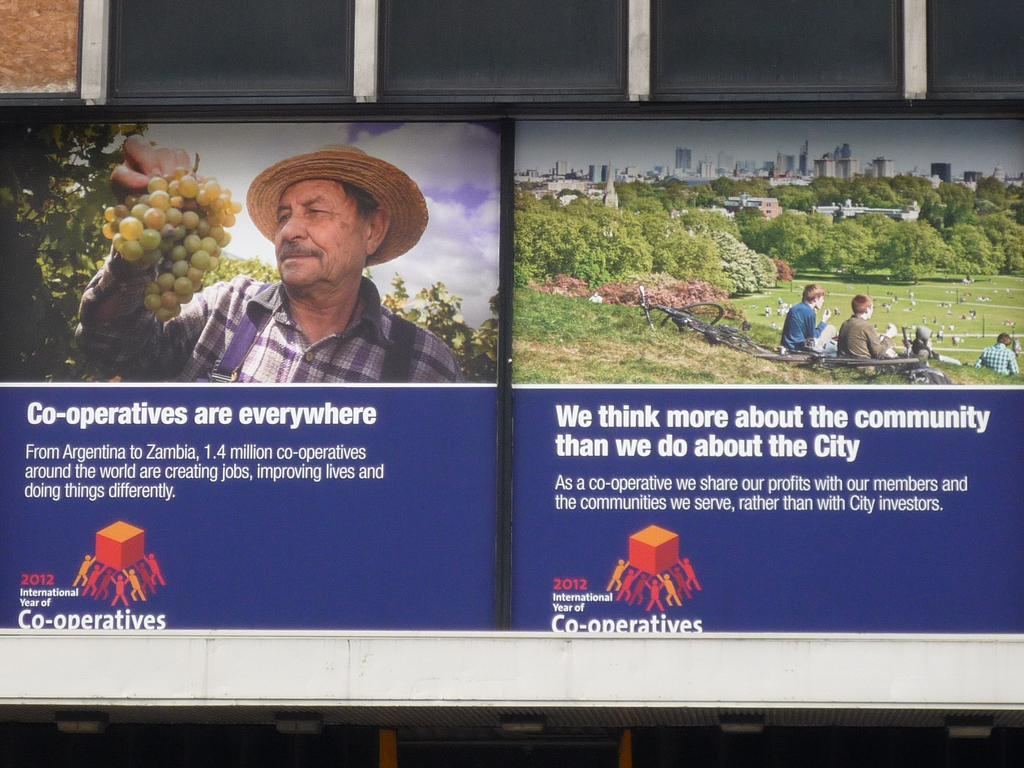What type of content can be found in the image? There is text and a logo in the image. What is the person in the image holding? The person is holding a bunch of grapes in the image. What can be seen in the background of the image? There are vehicles, a crowd on grass, trees, buildings, and the sky visible in the image. How can you tell that the image might be edited? The image appears to be an edited photo. How many twigs are being used to support the cellar in the image? There is no cellar or twigs present in the image. What type of wheel is visible on the vehicles in the image? The image does not provide enough detail to determine the type of wheels on the vehicles. 